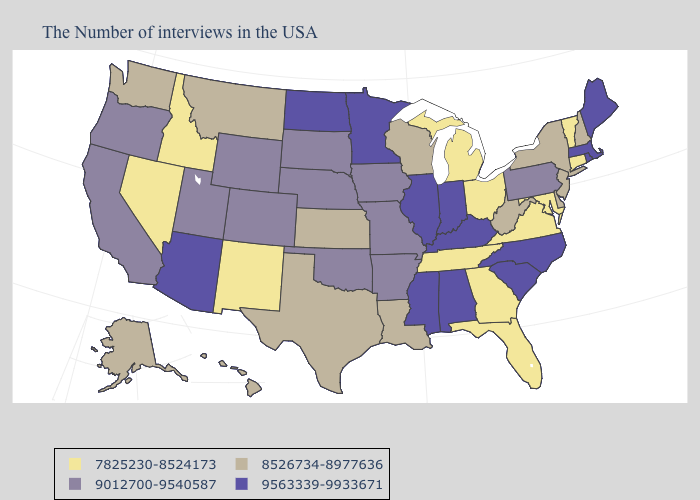What is the value of Connecticut?
Be succinct. 7825230-8524173. What is the lowest value in the USA?
Quick response, please. 7825230-8524173. Does South Carolina have a higher value than Kentucky?
Be succinct. No. Name the states that have a value in the range 9012700-9540587?
Concise answer only. Pennsylvania, Missouri, Arkansas, Iowa, Nebraska, Oklahoma, South Dakota, Wyoming, Colorado, Utah, California, Oregon. Which states have the lowest value in the Northeast?
Short answer required. Vermont, Connecticut. Which states hav the highest value in the West?
Be succinct. Arizona. Name the states that have a value in the range 8526734-8977636?
Give a very brief answer. New Hampshire, New York, New Jersey, Delaware, West Virginia, Wisconsin, Louisiana, Kansas, Texas, Montana, Washington, Alaska, Hawaii. What is the highest value in states that border New Jersey?
Give a very brief answer. 9012700-9540587. What is the highest value in the USA?
Give a very brief answer. 9563339-9933671. What is the value of North Dakota?
Short answer required. 9563339-9933671. Name the states that have a value in the range 9012700-9540587?
Be succinct. Pennsylvania, Missouri, Arkansas, Iowa, Nebraska, Oklahoma, South Dakota, Wyoming, Colorado, Utah, California, Oregon. Name the states that have a value in the range 7825230-8524173?
Quick response, please. Vermont, Connecticut, Maryland, Virginia, Ohio, Florida, Georgia, Michigan, Tennessee, New Mexico, Idaho, Nevada. Name the states that have a value in the range 9012700-9540587?
Concise answer only. Pennsylvania, Missouri, Arkansas, Iowa, Nebraska, Oklahoma, South Dakota, Wyoming, Colorado, Utah, California, Oregon. What is the highest value in the South ?
Concise answer only. 9563339-9933671. What is the value of Nebraska?
Short answer required. 9012700-9540587. 